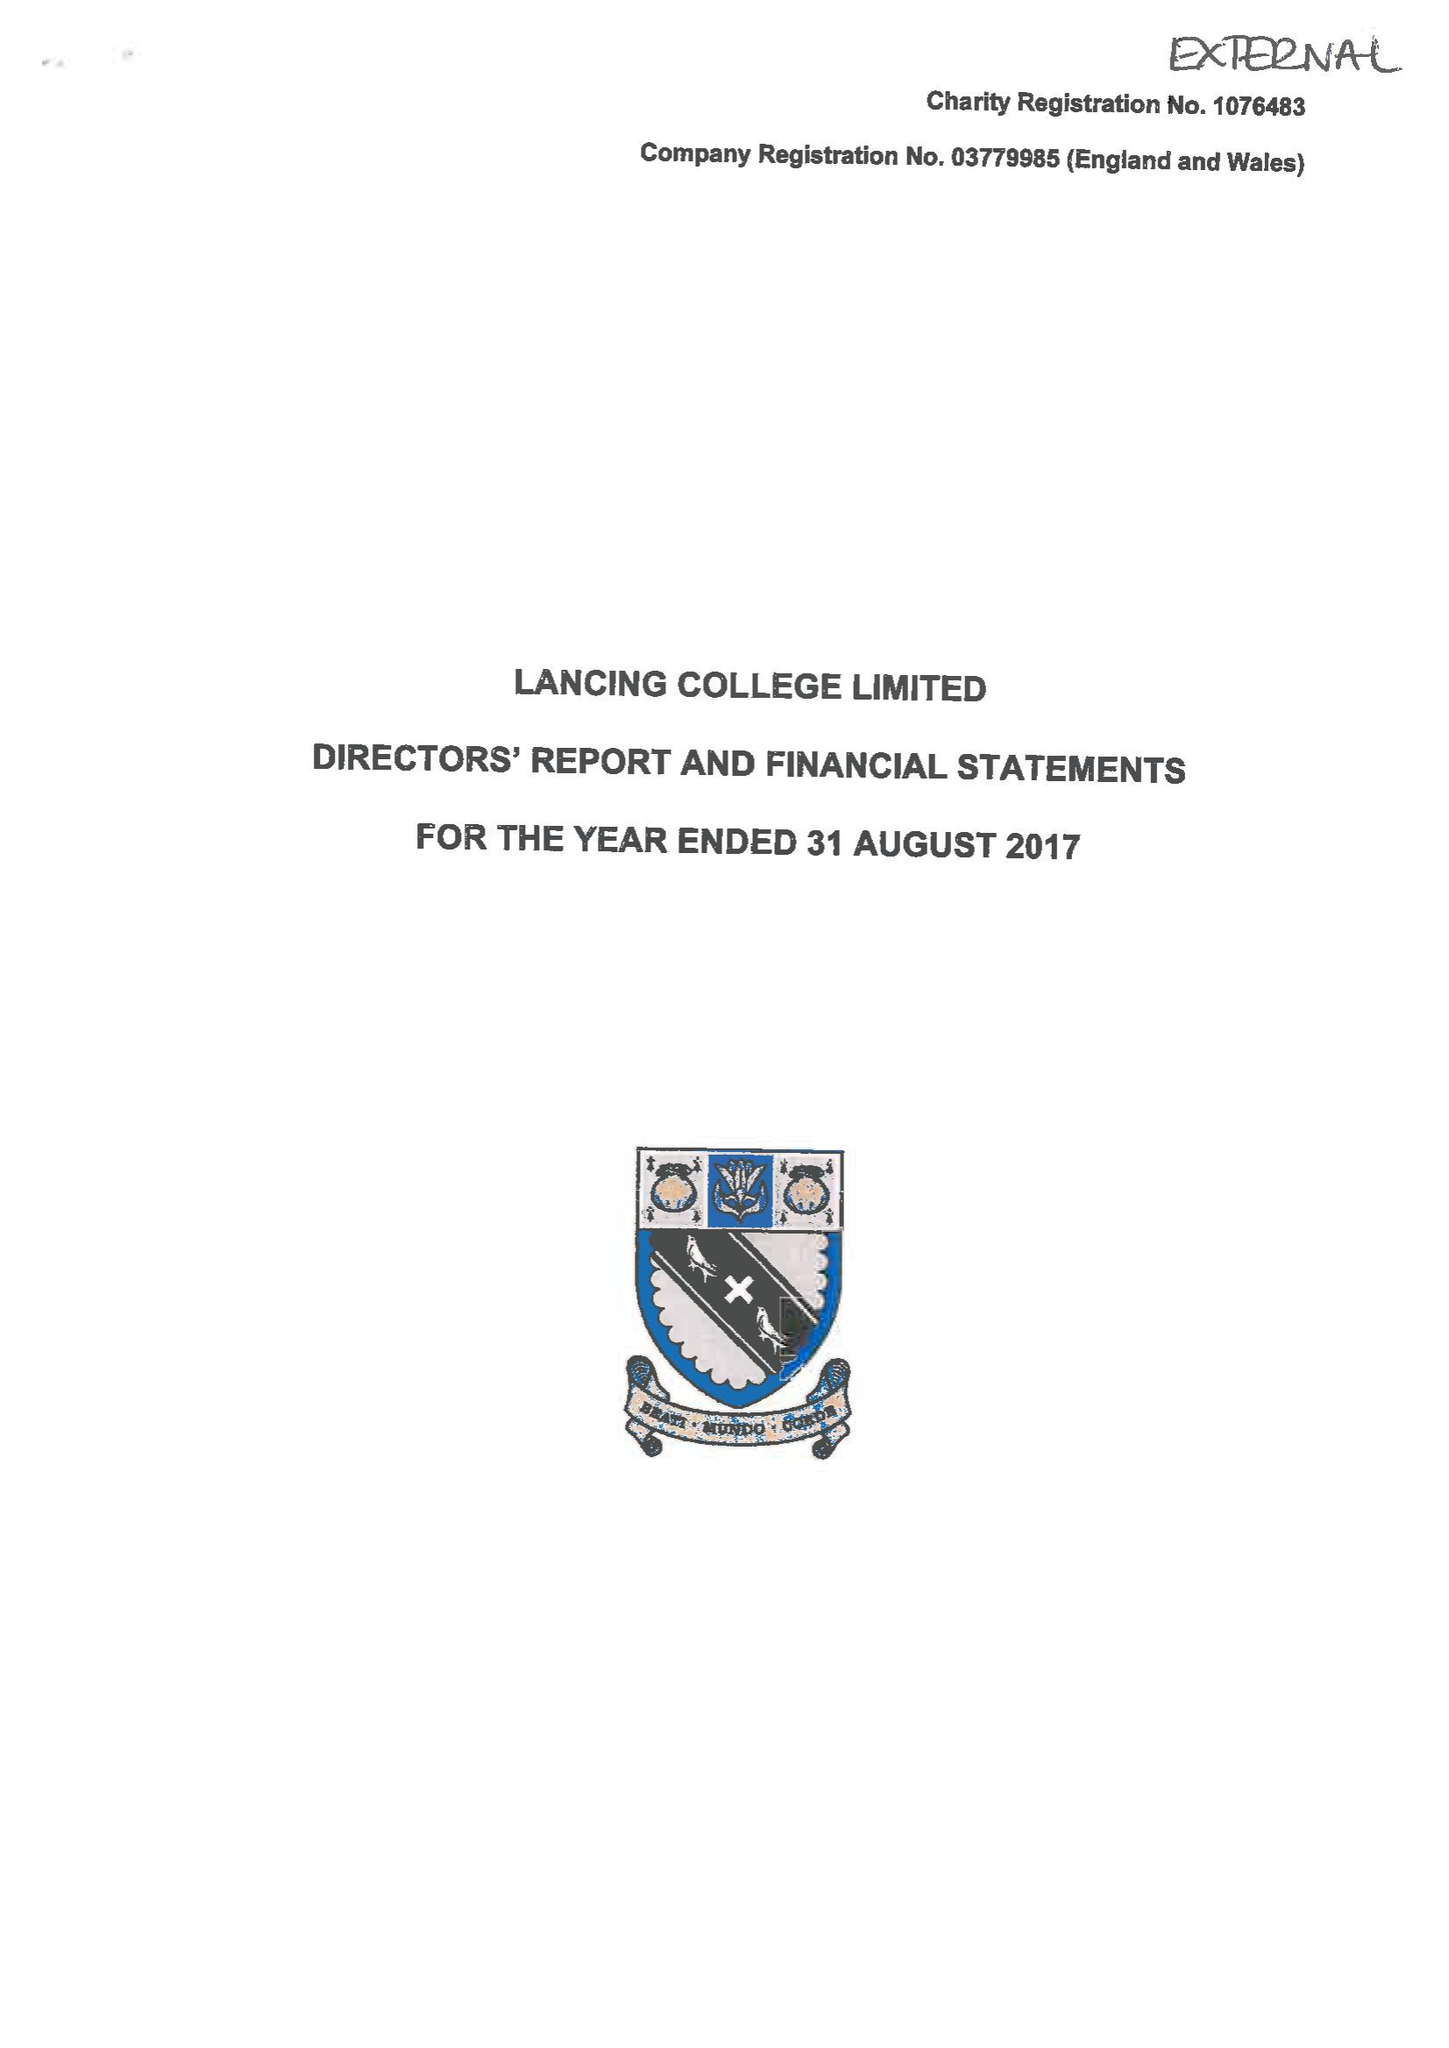What is the value for the charity_name?
Answer the question using a single word or phrase. Lancing College Ltd. 